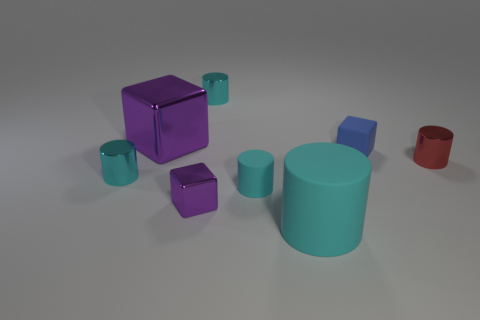There is a purple metal thing in front of the blue rubber object; is it the same size as the large shiny object?
Give a very brief answer. No. Is there a small shiny cube that has the same color as the large shiny cube?
Give a very brief answer. Yes. Are there any tiny cyan things right of the tiny shiny thing right of the big cyan matte object?
Make the answer very short. No. Is there a large green block made of the same material as the blue thing?
Your answer should be compact. No. What is the large cyan cylinder to the right of the cylinder behind the red metal cylinder made of?
Give a very brief answer. Rubber. What is the thing that is both on the right side of the big cyan rubber thing and left of the red metallic object made of?
Give a very brief answer. Rubber. Are there an equal number of small red things on the left side of the big cyan cylinder and tiny blue things?
Your answer should be compact. No. How many other small metallic things have the same shape as the tiny purple metallic object?
Your answer should be very brief. 0. How big is the purple object that is to the left of the tiny metal object that is in front of the small cyan cylinder left of the big shiny object?
Your answer should be compact. Large. Is the small block behind the red metal cylinder made of the same material as the small red cylinder?
Provide a short and direct response. No. 